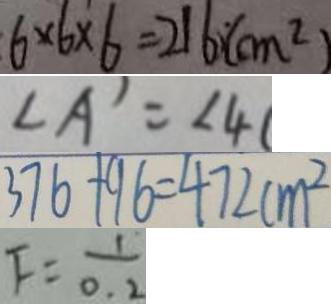Convert formula to latex. <formula><loc_0><loc_0><loc_500><loc_500>6 \times 6 \times 6 = 2 1 6 ( c m ^ { 2 } ) 
 \angle A ^ { \prime } = \angle 4 ( 
 3 7 6 + 9 6 = 4 7 2 c m ^ { 2 } 
 F = \frac { 1 } { 0 . 2 }</formula> 